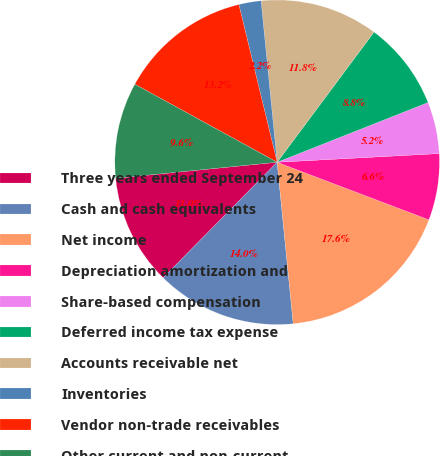Convert chart. <chart><loc_0><loc_0><loc_500><loc_500><pie_chart><fcel>Three years ended September 24<fcel>Cash and cash equivalents<fcel>Net income<fcel>Depreciation amortization and<fcel>Share-based compensation<fcel>Deferred income tax expense<fcel>Accounts receivable net<fcel>Inventories<fcel>Vendor non-trade receivables<fcel>Other current and non-current<nl><fcel>11.03%<fcel>13.97%<fcel>17.65%<fcel>6.62%<fcel>5.15%<fcel>8.82%<fcel>11.76%<fcel>2.21%<fcel>13.23%<fcel>9.56%<nl></chart> 